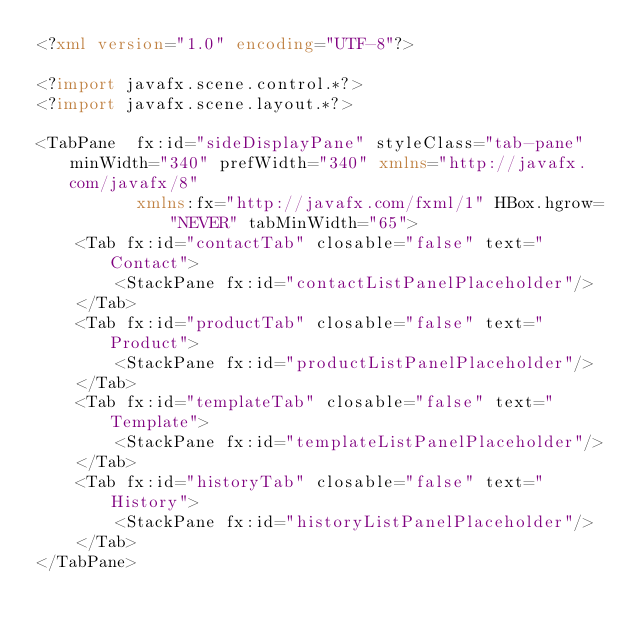<code> <loc_0><loc_0><loc_500><loc_500><_XML_><?xml version="1.0" encoding="UTF-8"?>

<?import javafx.scene.control.*?>
<?import javafx.scene.layout.*?>

<TabPane  fx:id="sideDisplayPane" styleClass="tab-pane" minWidth="340" prefWidth="340" xmlns="http://javafx.com/javafx/8"
          xmlns:fx="http://javafx.com/fxml/1" HBox.hgrow="NEVER" tabMinWidth="65">
    <Tab fx:id="contactTab" closable="false" text="Contact">
        <StackPane fx:id="contactListPanelPlaceholder"/>
    </Tab>
    <Tab fx:id="productTab" closable="false" text="Product">
        <StackPane fx:id="productListPanelPlaceholder"/>
    </Tab>
    <Tab fx:id="templateTab" closable="false" text="Template">
        <StackPane fx:id="templateListPanelPlaceholder"/>
    </Tab>
    <Tab fx:id="historyTab" closable="false" text="History">
        <StackPane fx:id="historyListPanelPlaceholder"/>
    </Tab>
</TabPane>
</code> 